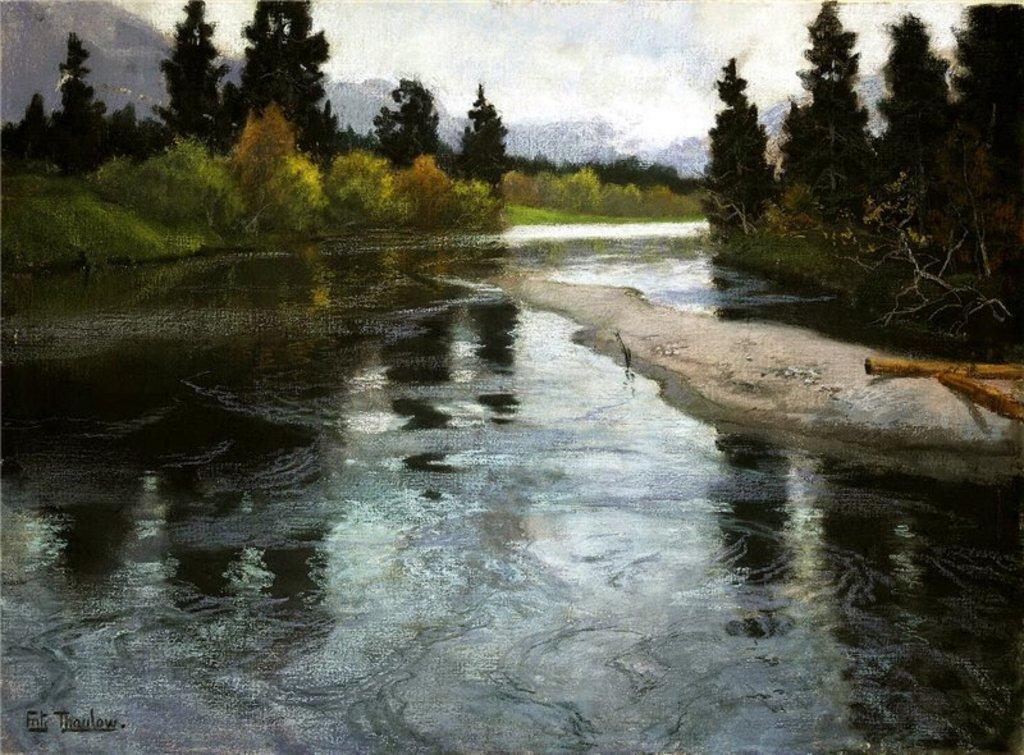Can you describe this image briefly? In this picture there is water and there are trees on either sides of it and there are mountains in the background. 